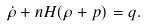<formula> <loc_0><loc_0><loc_500><loc_500>\dot { \rho } + n H ( \rho + p ) = q .</formula> 